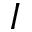Convert formula to latex. <formula><loc_0><loc_0><loc_500><loc_500>I</formula> 